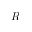<formula> <loc_0><loc_0><loc_500><loc_500>R</formula> 